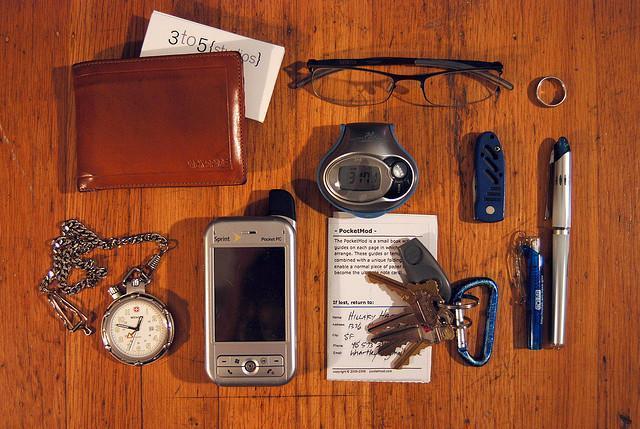How many knives are in the picture?
Give a very brief answer. 1. How many clocks are visible?
Give a very brief answer. 2. 